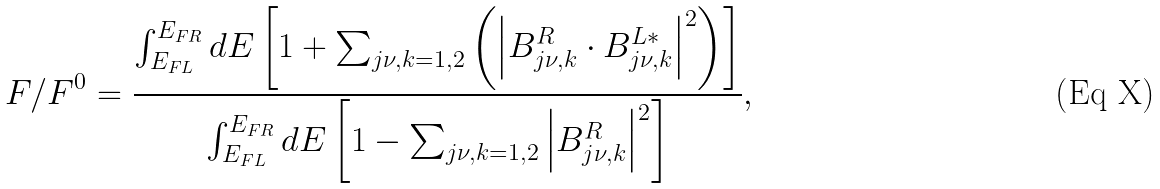<formula> <loc_0><loc_0><loc_500><loc_500>F / F ^ { 0 } = \frac { \int _ { E _ { F L } } ^ { E _ { F R } } d E \left [ 1 + \sum _ { j \nu , k = 1 , 2 } \left ( \left | B _ { j \nu , k } ^ { R } \cdot B _ { j \nu , k } ^ { L \ast } \right | ^ { 2 } \right ) \right ] } { \int _ { E _ { F L } } ^ { E _ { F R } } d E \left [ 1 - \sum _ { j \nu , k = 1 , 2 } \left | B _ { j \nu , k } ^ { R } \right | ^ { 2 } \right ] } ,</formula> 